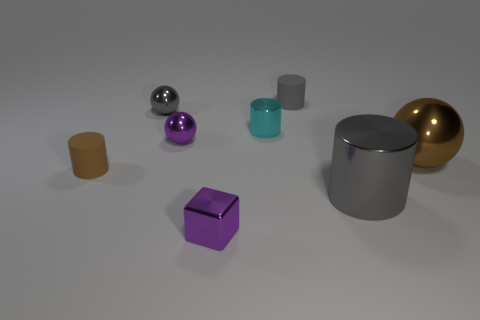Is there another small shiny thing of the same shape as the brown metallic object?
Offer a very short reply. Yes. What is the shape of the gray metal object that is the same size as the brown metal thing?
Offer a terse response. Cylinder. How many small rubber things have the same color as the big metallic sphere?
Make the answer very short. 1. How big is the sphere to the right of the purple cube?
Your answer should be compact. Large. What number of brown matte blocks are the same size as the gray matte object?
Keep it short and to the point. 0. There is a tiny cylinder that is the same material as the large brown ball; what is its color?
Your answer should be compact. Cyan. Is the number of tiny gray things that are to the right of the gray sphere less than the number of tiny purple things?
Ensure brevity in your answer.  Yes. What shape is the brown thing that is made of the same material as the tiny cyan thing?
Ensure brevity in your answer.  Sphere. What number of metallic things are tiny cyan spheres or tiny gray cylinders?
Your answer should be compact. 0. Are there the same number of gray metal spheres that are in front of the purple ball and big blue metallic cylinders?
Provide a short and direct response. Yes. 